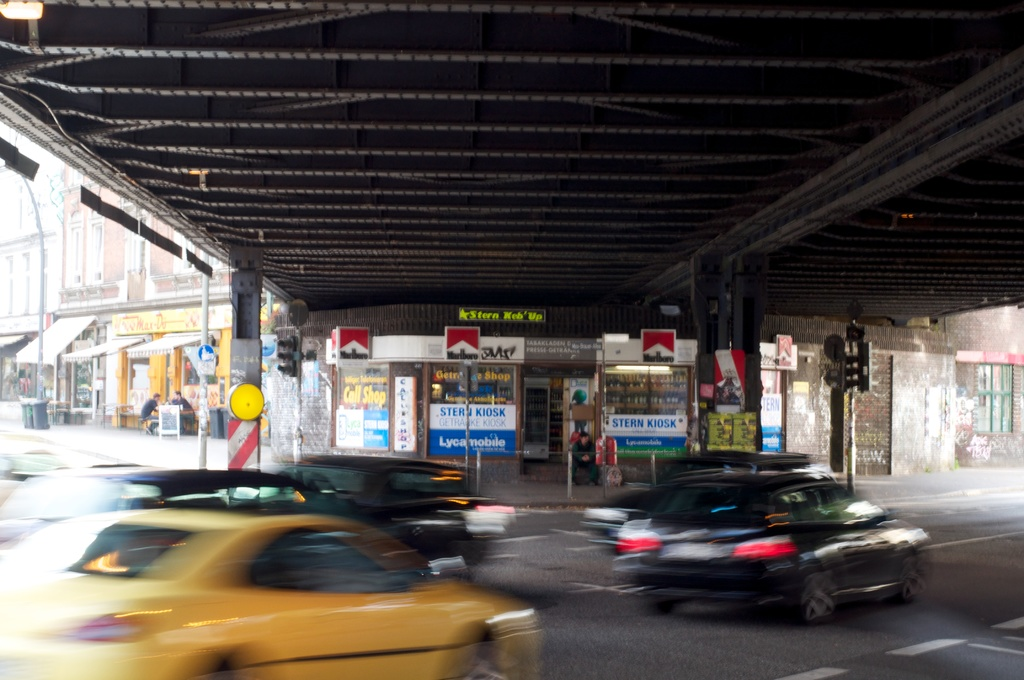What types of businesses can be seen under the bridge in the image? Under the bridge, there are several small businesses, including a kiosk, a gift shop, and what appears to be a small grocery store. Are there any visible signs or advertisements on the businesses? Yes, there are multiple advertisements and signs on the businesses, including one for Marlboro cigarettes, and various posters covering local events or offerings. 